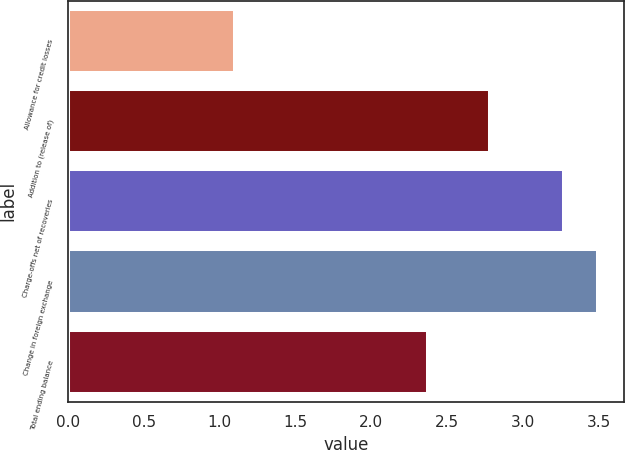<chart> <loc_0><loc_0><loc_500><loc_500><bar_chart><fcel>Allowance for credit losses<fcel>Addition to (release of)<fcel>Charge-offs net of recoveries<fcel>Change in foreign exchange<fcel>Total ending balance<nl><fcel>1.1<fcel>2.78<fcel>3.27<fcel>3.49<fcel>2.37<nl></chart> 